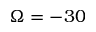Convert formula to latex. <formula><loc_0><loc_0><loc_500><loc_500>\Omega = - 3 0</formula> 